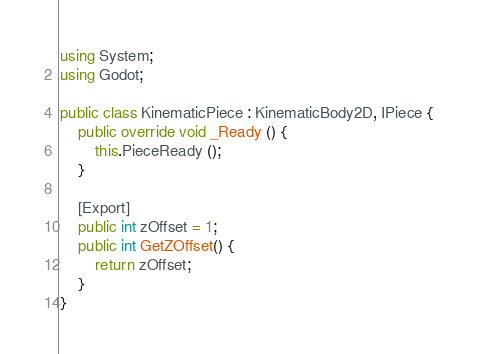<code> <loc_0><loc_0><loc_500><loc_500><_C#_>using System;
using Godot;

public class KinematicPiece : KinematicBody2D, IPiece {
	public override void _Ready () {
		this.PieceReady ();
	}
		
	[Export]
	public int zOffset = 1;
	public int GetZOffset() {
		return zOffset;
	}
}
</code> 